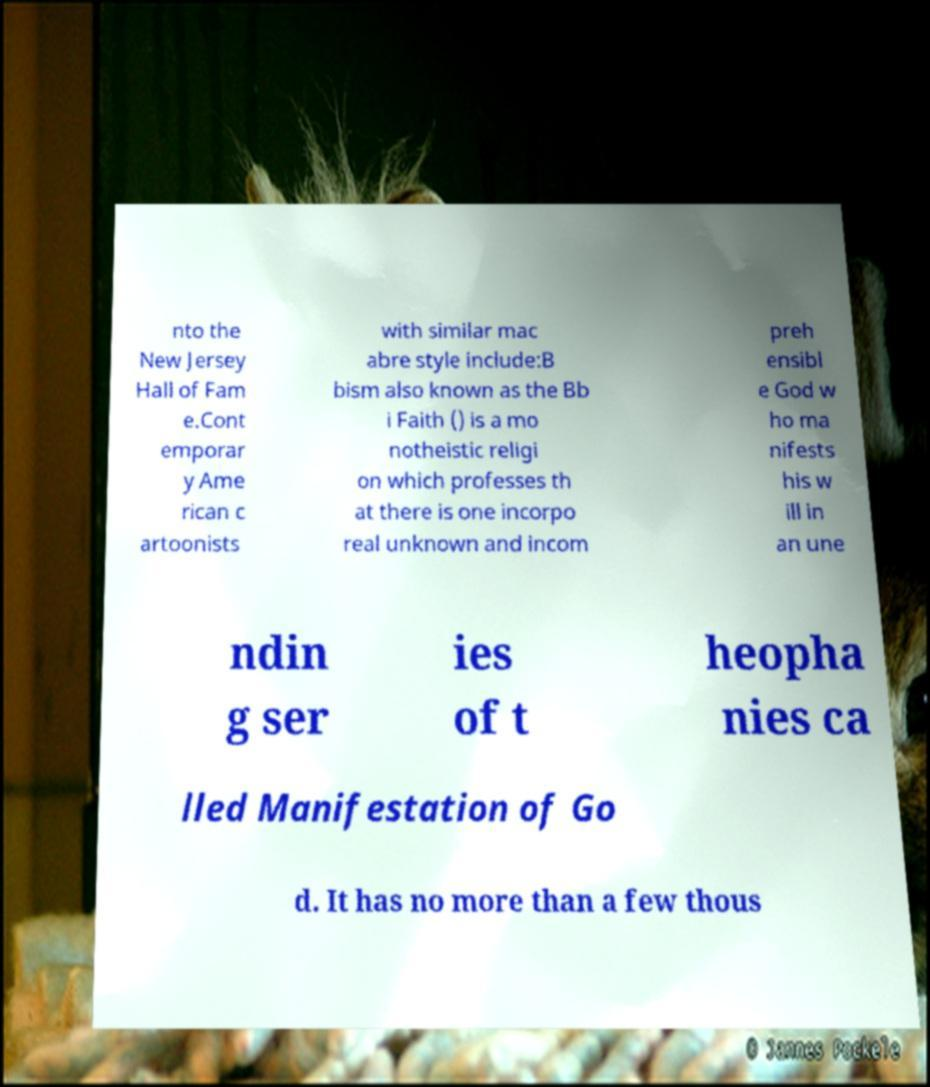Please read and relay the text visible in this image. What does it say? nto the New Jersey Hall of Fam e.Cont emporar y Ame rican c artoonists with similar mac abre style include:B bism also known as the Bb i Faith () is a mo notheistic religi on which professes th at there is one incorpo real unknown and incom preh ensibl e God w ho ma nifests his w ill in an une ndin g ser ies of t heopha nies ca lled Manifestation of Go d. It has no more than a few thous 